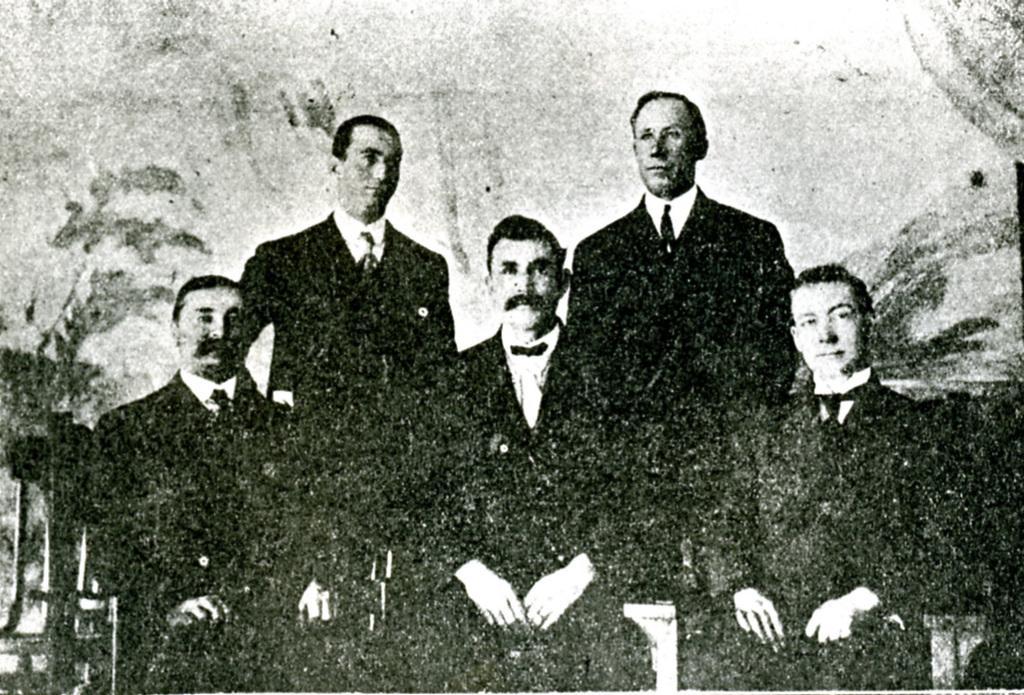In one or two sentences, can you explain what this image depicts? This image looks like an edited photo in which I can see three persons are sitting on the chairs and two persons are standing. The background is not clear. 